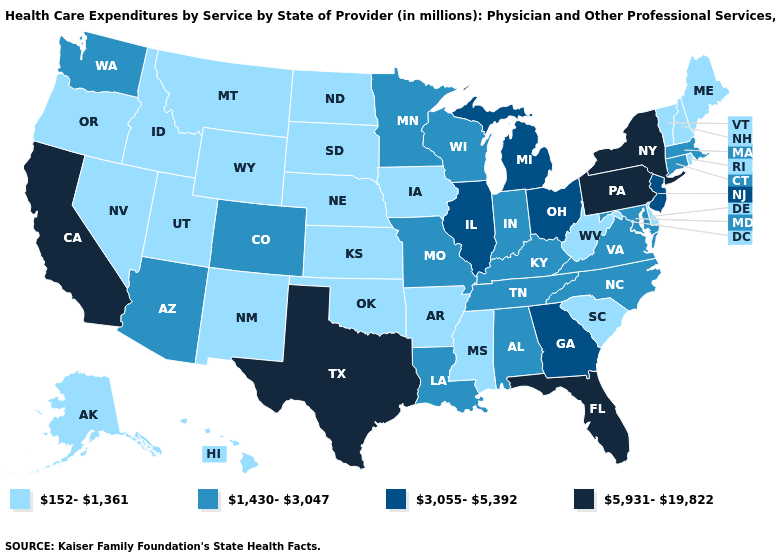Among the states that border North Dakota , which have the lowest value?
Be succinct. Montana, South Dakota. What is the value of Pennsylvania?
Answer briefly. 5,931-19,822. What is the highest value in the USA?
Keep it brief. 5,931-19,822. What is the value of Idaho?
Concise answer only. 152-1,361. Which states hav the highest value in the West?
Short answer required. California. What is the value of Delaware?
Quick response, please. 152-1,361. Among the states that border North Carolina , does Tennessee have the lowest value?
Write a very short answer. No. What is the value of Maine?
Write a very short answer. 152-1,361. What is the lowest value in the USA?
Be succinct. 152-1,361. What is the lowest value in the West?
Concise answer only. 152-1,361. What is the highest value in states that border Nebraska?
Quick response, please. 1,430-3,047. Which states have the lowest value in the West?
Keep it brief. Alaska, Hawaii, Idaho, Montana, Nevada, New Mexico, Oregon, Utah, Wyoming. What is the lowest value in the USA?
Concise answer only. 152-1,361. Does the map have missing data?
Write a very short answer. No. What is the lowest value in states that border Indiana?
Answer briefly. 1,430-3,047. 